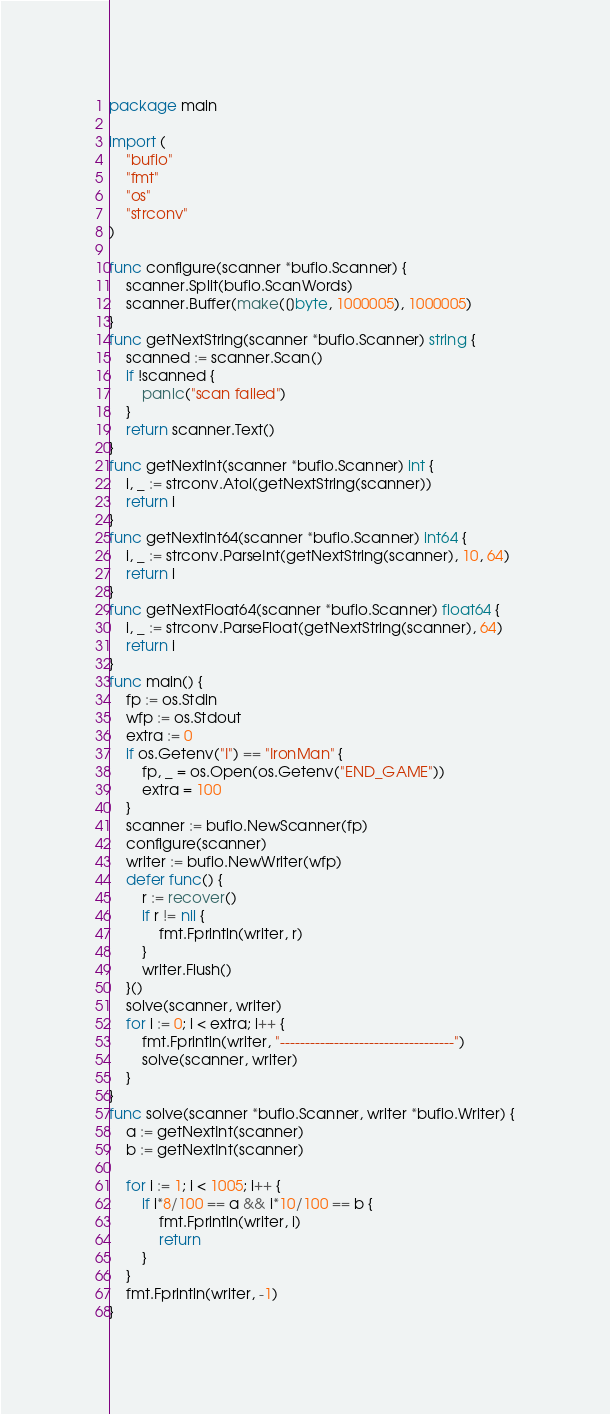<code> <loc_0><loc_0><loc_500><loc_500><_Go_>package main

import (
	"bufio"
	"fmt"
	"os"
	"strconv"
)

func configure(scanner *bufio.Scanner) {
	scanner.Split(bufio.ScanWords)
	scanner.Buffer(make([]byte, 1000005), 1000005)
}
func getNextString(scanner *bufio.Scanner) string {
	scanned := scanner.Scan()
	if !scanned {
		panic("scan failed")
	}
	return scanner.Text()
}
func getNextInt(scanner *bufio.Scanner) int {
	i, _ := strconv.Atoi(getNextString(scanner))
	return i
}
func getNextInt64(scanner *bufio.Scanner) int64 {
	i, _ := strconv.ParseInt(getNextString(scanner), 10, 64)
	return i
}
func getNextFloat64(scanner *bufio.Scanner) float64 {
	i, _ := strconv.ParseFloat(getNextString(scanner), 64)
	return i
}
func main() {
	fp := os.Stdin
	wfp := os.Stdout
	extra := 0
	if os.Getenv("I") == "IronMan" {
		fp, _ = os.Open(os.Getenv("END_GAME"))
		extra = 100
	}
	scanner := bufio.NewScanner(fp)
	configure(scanner)
	writer := bufio.NewWriter(wfp)
	defer func() {
		r := recover()
		if r != nil {
			fmt.Fprintln(writer, r)
		}
		writer.Flush()
	}()
	solve(scanner, writer)
	for i := 0; i < extra; i++ {
		fmt.Fprintln(writer, "-----------------------------------")
		solve(scanner, writer)
	}
}
func solve(scanner *bufio.Scanner, writer *bufio.Writer) {
	a := getNextInt(scanner)
	b := getNextInt(scanner)

	for i := 1; i < 1005; i++ {
		if i*8/100 == a && i*10/100 == b {
			fmt.Fprintln(writer, i)
			return
		}
	}
	fmt.Fprintln(writer, -1)
}
</code> 